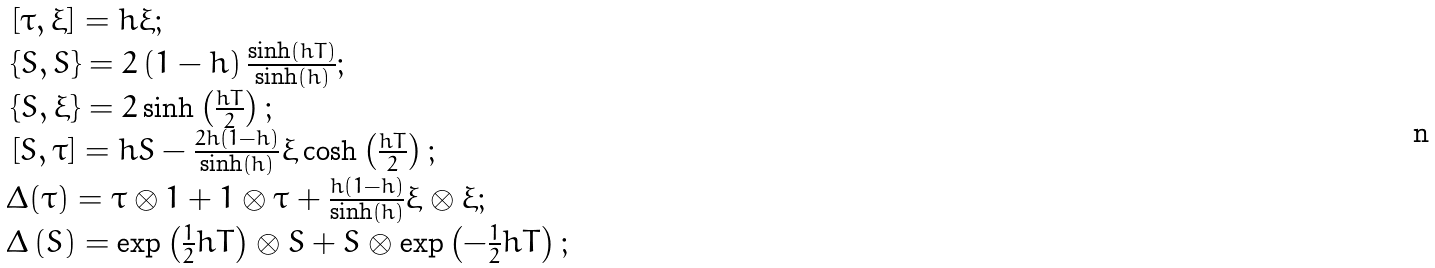Convert formula to latex. <formula><loc_0><loc_0><loc_500><loc_500>\begin{array} { l } \, \left [ \tau , \xi \right ] = h \xi ; \\ \, \left \{ S , S \right \} = 2 \left ( 1 - h \right ) \frac { \sinh ( h T ) } { \sinh ( h ) } ; \\ \, \left \{ S , \xi \right \} = 2 \sinh \left ( \frac { h T } 2 \right ) ; \\ \, \left [ S , \tau \right ] = h S - \frac { 2 h \left ( 1 - h \right ) } { \sinh \left ( h \right ) } \xi \cosh \left ( \frac { h T } 2 \right ) ; \\ \Delta ( \tau ) = \tau \otimes 1 + 1 \otimes \tau + \frac { h ( 1 - h ) } { \sinh \left ( h \right ) } \xi \otimes \xi ; \\ \Delta \left ( S \right ) = \exp \left ( \frac { 1 } { 2 } h T \right ) \otimes S + S \otimes \exp \left ( - \frac { 1 } { 2 } h T \right ) ; \end{array}</formula> 